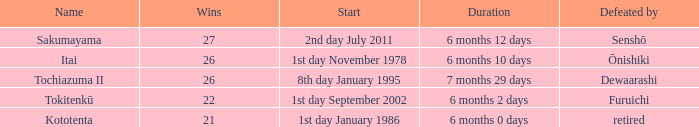Which duration was defeated by retired? 6 months 0 days. 